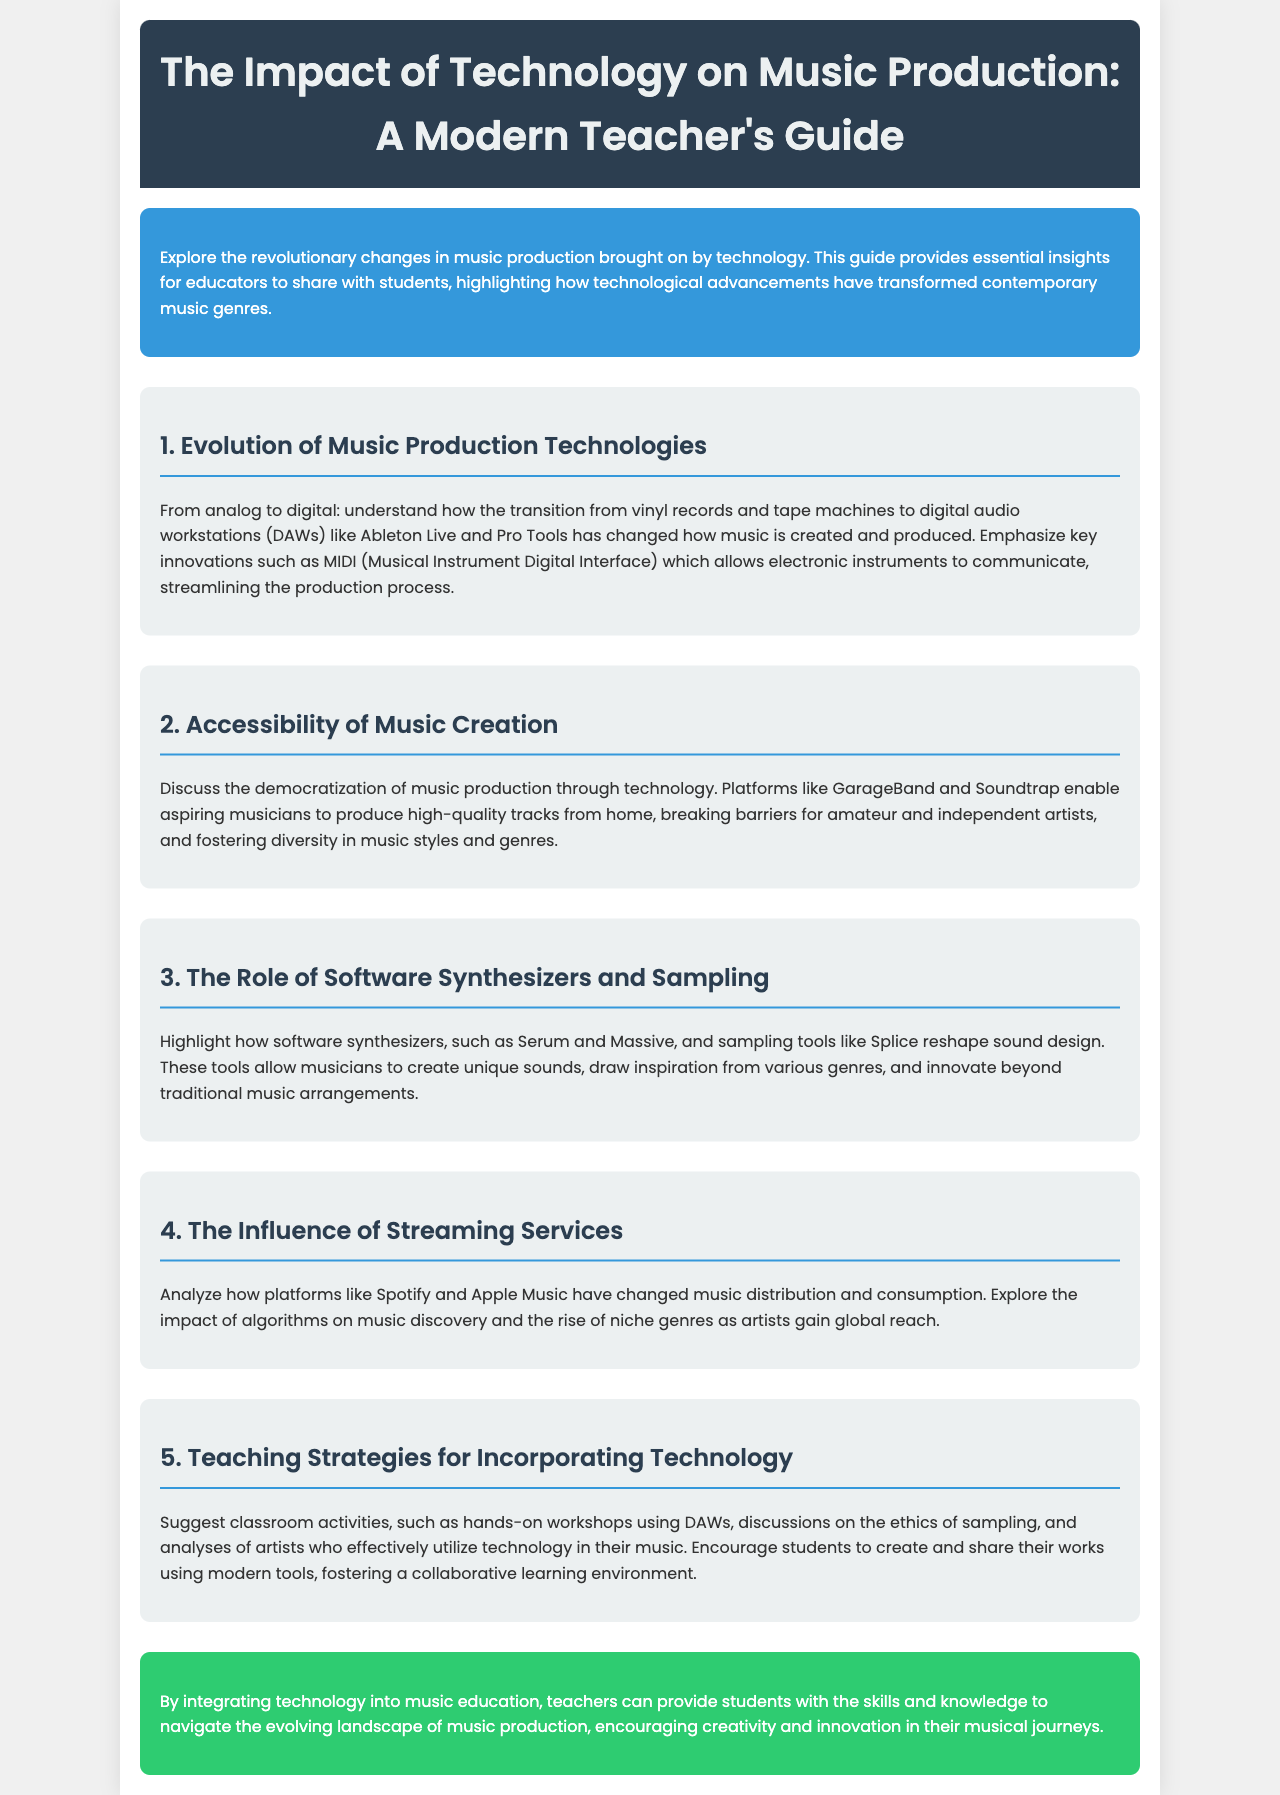What is the title of the guide? The title reflects the main focus of the document and is prominently displayed in the header.
Answer: The Impact of Technology on Music Production: A Modern Teacher's Guide What is discussed in section 1? Section 1 covers the transition from older music production methods to modern technologies.
Answer: Evolution of Music Production Technologies Which platforms are mentioned for accessibility in music creation? The document provides examples of technology that has made music production more accessible, particularly for amateurs and independent artists.
Answer: GarageBand and Soundtrap What is the main purpose of the document? The introductory section explains the overall aim of the guide for educators teaching music.
Answer: To provide essential insights for educators Which tool is highlighted for sound design in section 3? This section emphasizes a specific type of software that impacts how musicians create sounds.
Answer: Software synthesizers What teaching strategy is suggested for incorporating technology? The document lists strategies that can be implemented within the classroom setting to teach students about technology in music.
Answer: Hands-on workshops using DAWs What is a key impact of streaming services according to section 4? The section analyzes how modern platforms influence the way music is consumed today.
Answer: Music discovery What benefits does technology provide for amateur musicians? This part of the document identifies the positive effects of tech advancements on new artists.
Answer: Democratization of music production 